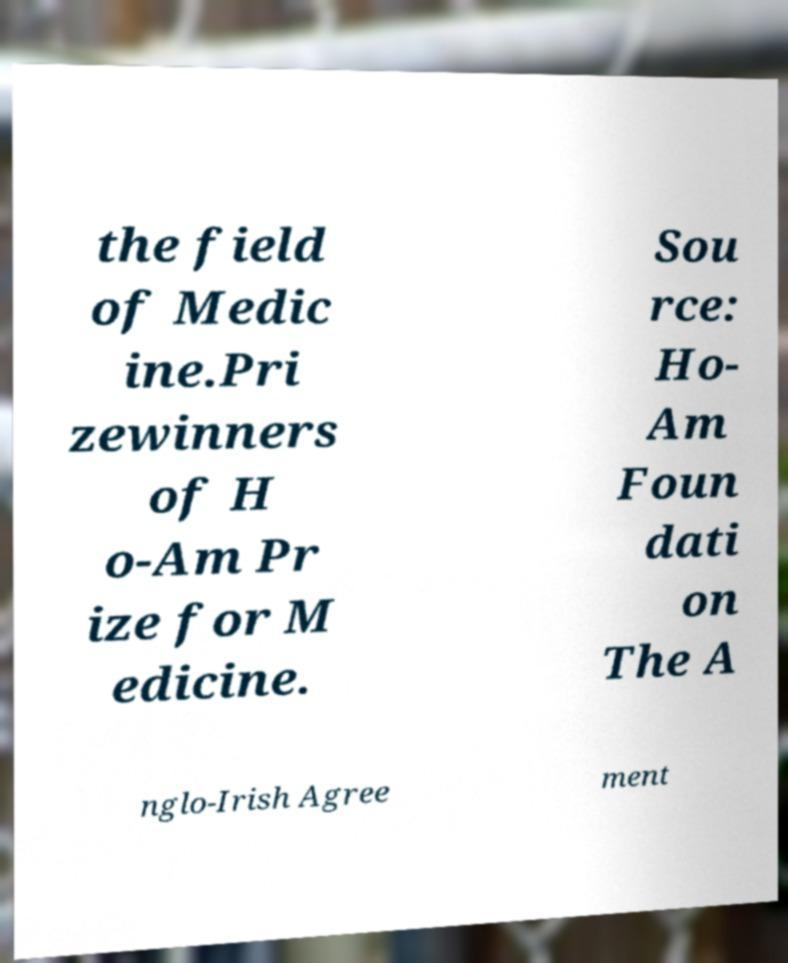Could you assist in decoding the text presented in this image and type it out clearly? the field of Medic ine.Pri zewinners of H o-Am Pr ize for M edicine. Sou rce: Ho- Am Foun dati on The A nglo-Irish Agree ment 